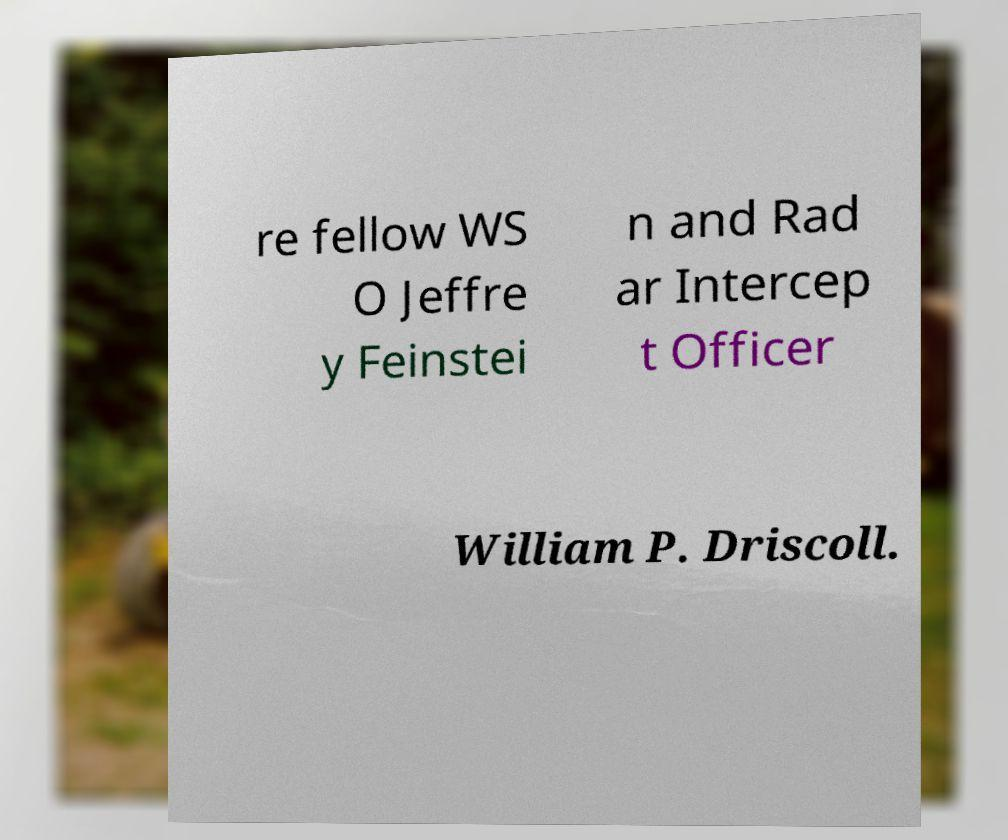Could you extract and type out the text from this image? re fellow WS O Jeffre y Feinstei n and Rad ar Intercep t Officer William P. Driscoll. 